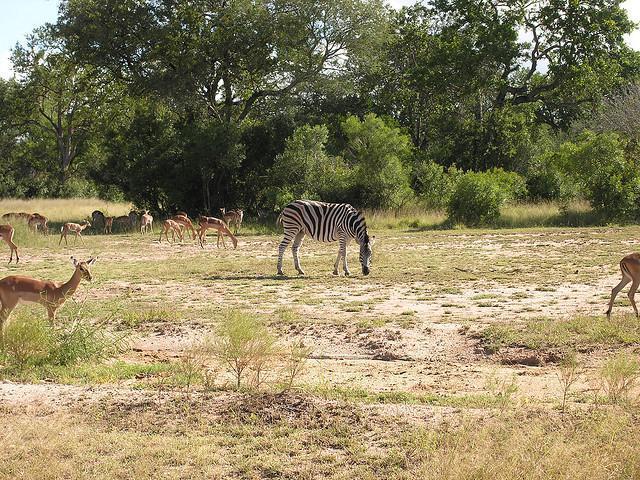How many zebra's?
Give a very brief answer. 1. 